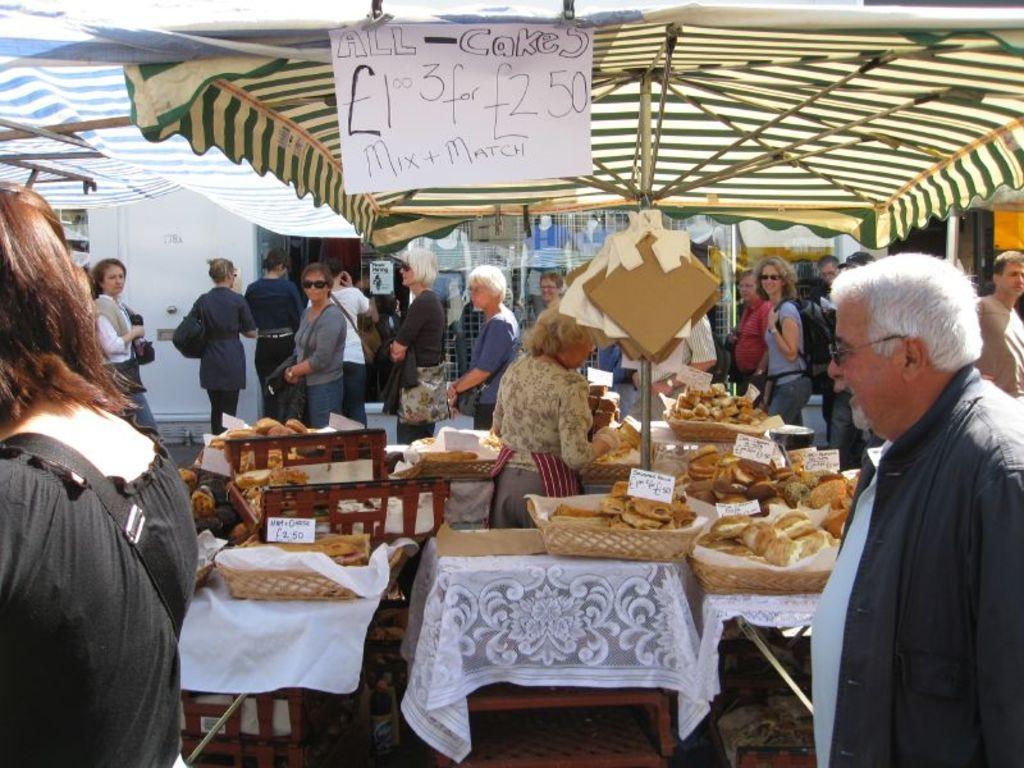Could you give a brief overview of what you see in this image? There are lot of crowd standing around food stalls under a tent. There are few cakes kept on bench. there is a label showing the price of food. 